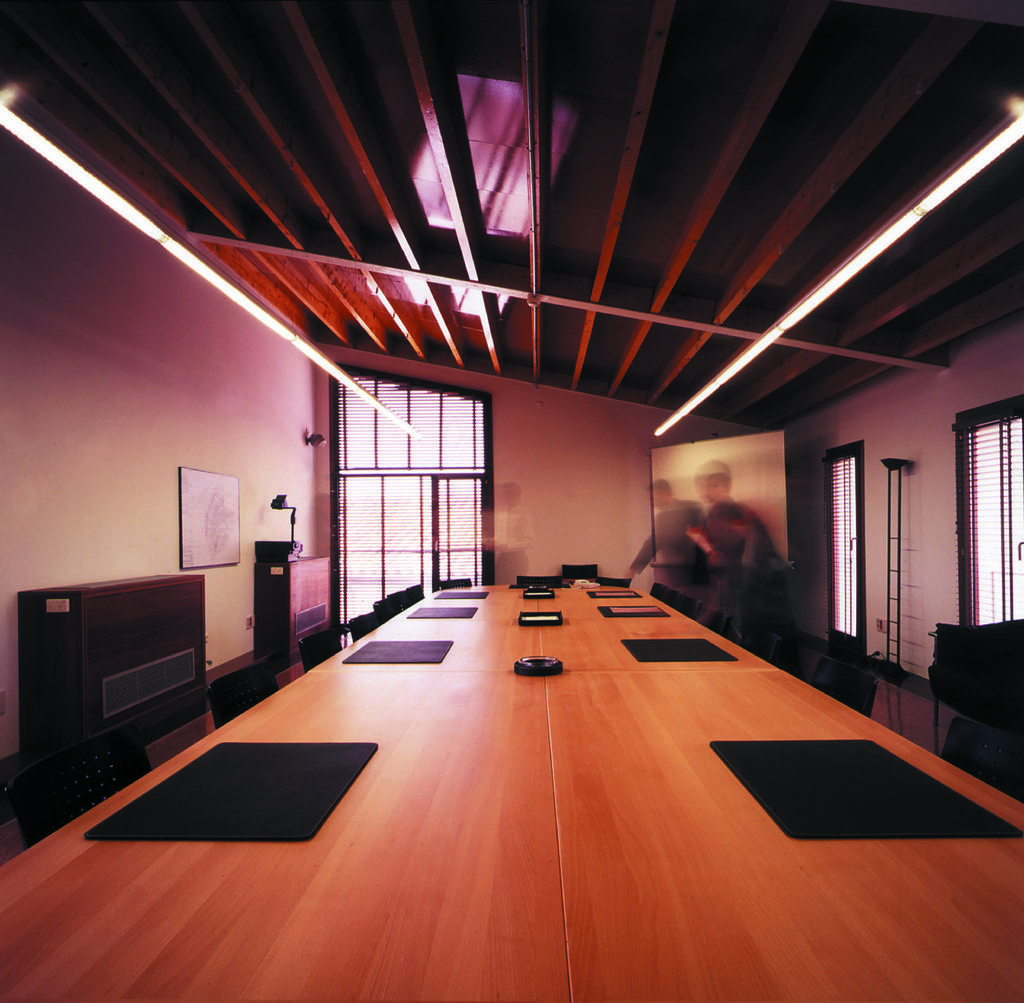Describe this image in one or two sentences. In the picture there is a room, in the room there is a table, on the there are some mat type items present, there are glass windows present, there are lights present on the roof, there are blur images of people present, on the wall there is a frame, there may be cupboards present near the wall. 